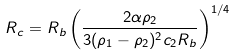<formula> <loc_0><loc_0><loc_500><loc_500>R _ { c } = R _ { b } \left ( \frac { 2 \alpha \rho _ { 2 } } { 3 ( \rho _ { 1 } - \rho _ { 2 } ) ^ { 2 } c _ { 2 } R _ { b } } \right ) ^ { 1 / 4 }</formula> 